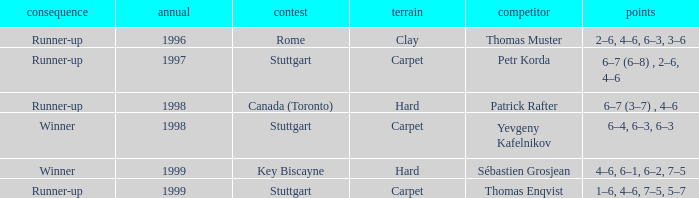What championship after 1997 was the score 1–6, 4–6, 7–5, 5–7? Stuttgart. 